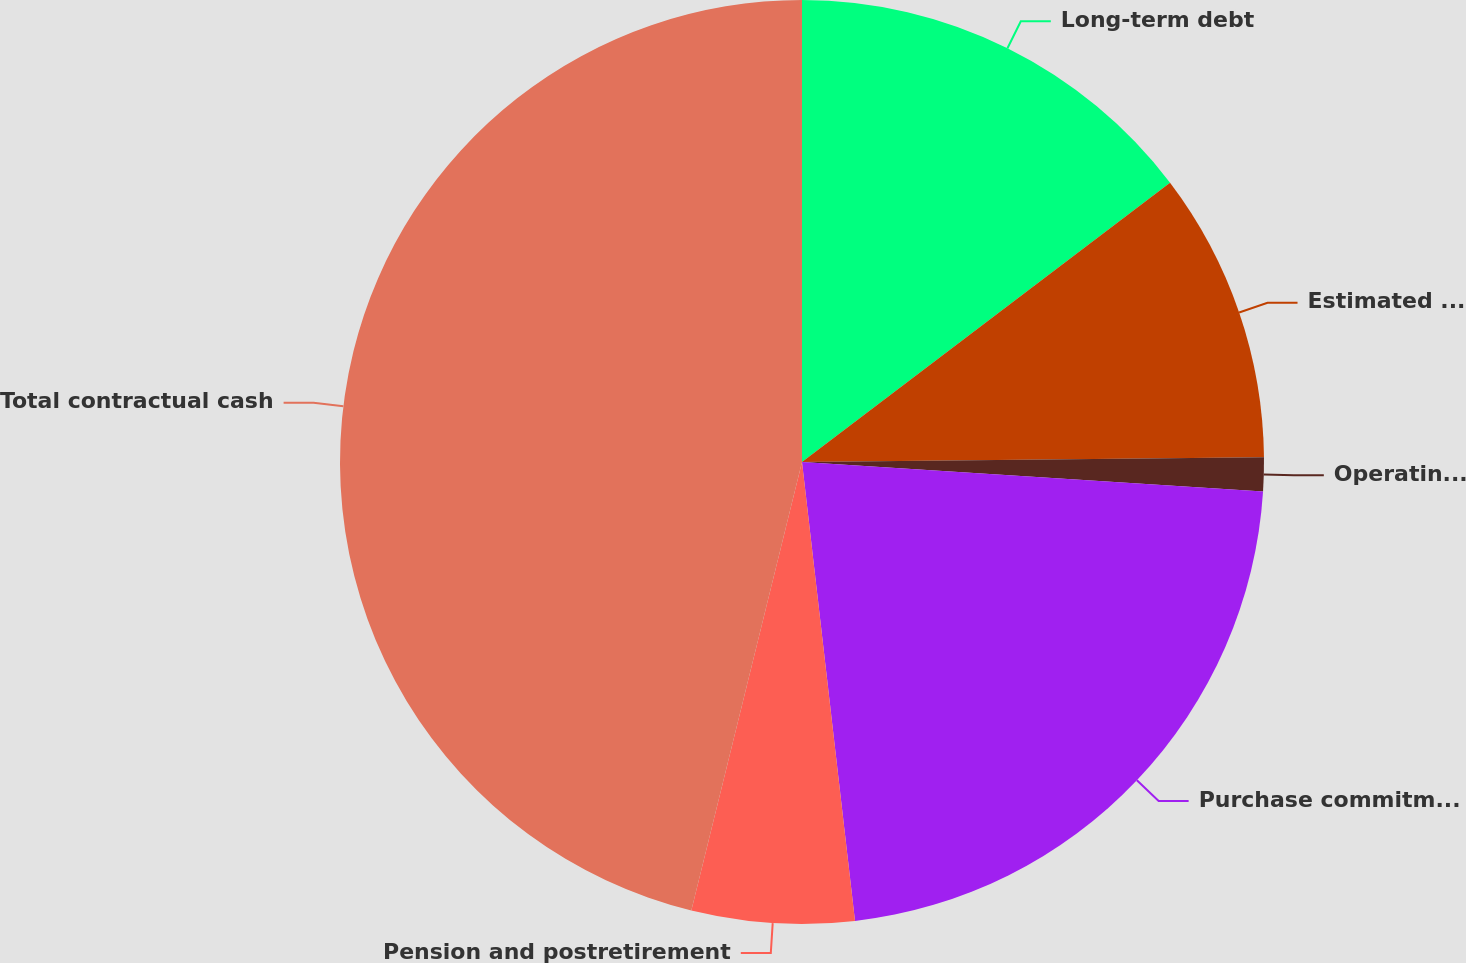<chart> <loc_0><loc_0><loc_500><loc_500><pie_chart><fcel>Long-term debt<fcel>Estimated interest payments on<fcel>Operating leases<fcel>Purchase commitments (b)<fcel>Pension and postretirement<fcel>Total contractual cash<nl><fcel>14.67%<fcel>10.17%<fcel>1.18%<fcel>22.15%<fcel>5.68%<fcel>46.15%<nl></chart> 